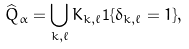<formula> <loc_0><loc_0><loc_500><loc_500>\widehat { Q } _ { \alpha } = \bigcup _ { k , \ell } K _ { k , \ell } { \mathbf 1 } \{ \delta _ { k , \ell } = 1 \} ,</formula> 